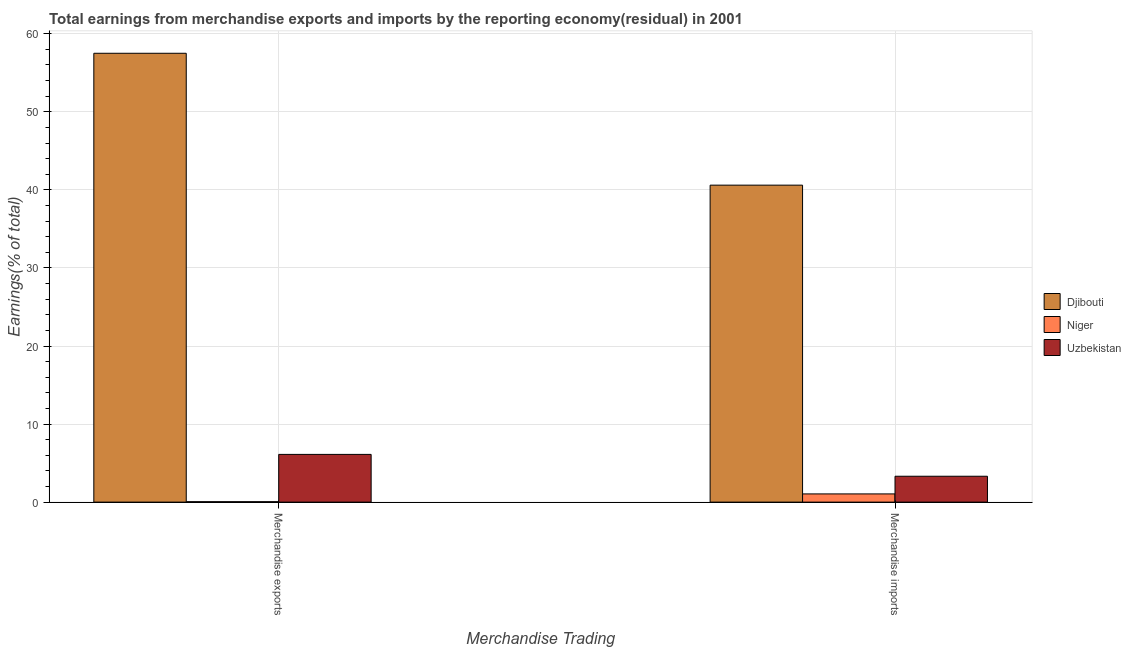How many different coloured bars are there?
Keep it short and to the point. 3. Are the number of bars per tick equal to the number of legend labels?
Ensure brevity in your answer.  Yes. Are the number of bars on each tick of the X-axis equal?
Offer a terse response. Yes. How many bars are there on the 2nd tick from the right?
Offer a terse response. 3. What is the earnings from merchandise imports in Uzbekistan?
Keep it short and to the point. 3.32. Across all countries, what is the maximum earnings from merchandise imports?
Your response must be concise. 40.61. Across all countries, what is the minimum earnings from merchandise imports?
Your response must be concise. 1.05. In which country was the earnings from merchandise exports maximum?
Your answer should be compact. Djibouti. In which country was the earnings from merchandise exports minimum?
Give a very brief answer. Niger. What is the total earnings from merchandise imports in the graph?
Give a very brief answer. 44.97. What is the difference between the earnings from merchandise exports in Uzbekistan and that in Djibouti?
Your response must be concise. -51.39. What is the difference between the earnings from merchandise exports in Djibouti and the earnings from merchandise imports in Uzbekistan?
Give a very brief answer. 54.18. What is the average earnings from merchandise exports per country?
Keep it short and to the point. 21.22. What is the difference between the earnings from merchandise imports and earnings from merchandise exports in Uzbekistan?
Your response must be concise. -2.8. What is the ratio of the earnings from merchandise imports in Djibouti to that in Niger?
Your answer should be compact. 38.57. What does the 2nd bar from the left in Merchandise exports represents?
Give a very brief answer. Niger. What does the 2nd bar from the right in Merchandise exports represents?
Offer a very short reply. Niger. How many bars are there?
Your answer should be compact. 6. Are the values on the major ticks of Y-axis written in scientific E-notation?
Give a very brief answer. No. Where does the legend appear in the graph?
Ensure brevity in your answer.  Center right. How many legend labels are there?
Give a very brief answer. 3. How are the legend labels stacked?
Your answer should be compact. Vertical. What is the title of the graph?
Keep it short and to the point. Total earnings from merchandise exports and imports by the reporting economy(residual) in 2001. Does "Monaco" appear as one of the legend labels in the graph?
Ensure brevity in your answer.  No. What is the label or title of the X-axis?
Make the answer very short. Merchandise Trading. What is the label or title of the Y-axis?
Your answer should be very brief. Earnings(% of total). What is the Earnings(% of total) in Djibouti in Merchandise exports?
Your answer should be compact. 57.5. What is the Earnings(% of total) in Niger in Merchandise exports?
Provide a succinct answer. 0.05. What is the Earnings(% of total) in Uzbekistan in Merchandise exports?
Offer a terse response. 6.11. What is the Earnings(% of total) in Djibouti in Merchandise imports?
Make the answer very short. 40.61. What is the Earnings(% of total) of Niger in Merchandise imports?
Your answer should be compact. 1.05. What is the Earnings(% of total) of Uzbekistan in Merchandise imports?
Your answer should be very brief. 3.32. Across all Merchandise Trading, what is the maximum Earnings(% of total) of Djibouti?
Ensure brevity in your answer.  57.5. Across all Merchandise Trading, what is the maximum Earnings(% of total) in Niger?
Offer a very short reply. 1.05. Across all Merchandise Trading, what is the maximum Earnings(% of total) in Uzbekistan?
Your response must be concise. 6.11. Across all Merchandise Trading, what is the minimum Earnings(% of total) in Djibouti?
Your answer should be compact. 40.61. Across all Merchandise Trading, what is the minimum Earnings(% of total) in Niger?
Your answer should be very brief. 0.05. Across all Merchandise Trading, what is the minimum Earnings(% of total) of Uzbekistan?
Offer a very short reply. 3.32. What is the total Earnings(% of total) of Djibouti in the graph?
Offer a very short reply. 98.11. What is the total Earnings(% of total) of Niger in the graph?
Your answer should be very brief. 1.11. What is the total Earnings(% of total) in Uzbekistan in the graph?
Keep it short and to the point. 9.43. What is the difference between the Earnings(% of total) in Djibouti in Merchandise exports and that in Merchandise imports?
Your response must be concise. 16.89. What is the difference between the Earnings(% of total) of Niger in Merchandise exports and that in Merchandise imports?
Your answer should be very brief. -1. What is the difference between the Earnings(% of total) of Uzbekistan in Merchandise exports and that in Merchandise imports?
Offer a terse response. 2.8. What is the difference between the Earnings(% of total) in Djibouti in Merchandise exports and the Earnings(% of total) in Niger in Merchandise imports?
Your answer should be compact. 56.45. What is the difference between the Earnings(% of total) in Djibouti in Merchandise exports and the Earnings(% of total) in Uzbekistan in Merchandise imports?
Offer a terse response. 54.18. What is the difference between the Earnings(% of total) of Niger in Merchandise exports and the Earnings(% of total) of Uzbekistan in Merchandise imports?
Keep it short and to the point. -3.26. What is the average Earnings(% of total) in Djibouti per Merchandise Trading?
Ensure brevity in your answer.  49.05. What is the average Earnings(% of total) in Niger per Merchandise Trading?
Provide a short and direct response. 0.55. What is the average Earnings(% of total) in Uzbekistan per Merchandise Trading?
Your response must be concise. 4.72. What is the difference between the Earnings(% of total) in Djibouti and Earnings(% of total) in Niger in Merchandise exports?
Ensure brevity in your answer.  57.45. What is the difference between the Earnings(% of total) in Djibouti and Earnings(% of total) in Uzbekistan in Merchandise exports?
Ensure brevity in your answer.  51.39. What is the difference between the Earnings(% of total) of Niger and Earnings(% of total) of Uzbekistan in Merchandise exports?
Keep it short and to the point. -6.06. What is the difference between the Earnings(% of total) of Djibouti and Earnings(% of total) of Niger in Merchandise imports?
Provide a succinct answer. 39.55. What is the difference between the Earnings(% of total) of Djibouti and Earnings(% of total) of Uzbekistan in Merchandise imports?
Your answer should be very brief. 37.29. What is the difference between the Earnings(% of total) of Niger and Earnings(% of total) of Uzbekistan in Merchandise imports?
Offer a terse response. -2.26. What is the ratio of the Earnings(% of total) of Djibouti in Merchandise exports to that in Merchandise imports?
Provide a succinct answer. 1.42. What is the ratio of the Earnings(% of total) in Niger in Merchandise exports to that in Merchandise imports?
Your response must be concise. 0.05. What is the ratio of the Earnings(% of total) in Uzbekistan in Merchandise exports to that in Merchandise imports?
Provide a succinct answer. 1.84. What is the difference between the highest and the second highest Earnings(% of total) of Djibouti?
Provide a succinct answer. 16.89. What is the difference between the highest and the second highest Earnings(% of total) of Uzbekistan?
Provide a succinct answer. 2.8. What is the difference between the highest and the lowest Earnings(% of total) in Djibouti?
Your answer should be very brief. 16.89. What is the difference between the highest and the lowest Earnings(% of total) in Niger?
Offer a very short reply. 1. What is the difference between the highest and the lowest Earnings(% of total) in Uzbekistan?
Ensure brevity in your answer.  2.8. 